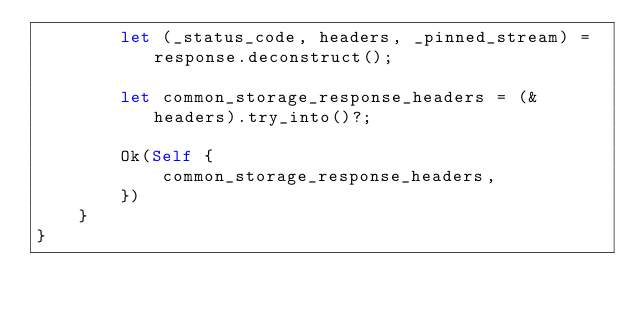<code> <loc_0><loc_0><loc_500><loc_500><_Rust_>        let (_status_code, headers, _pinned_stream) = response.deconstruct();

        let common_storage_response_headers = (&headers).try_into()?;

        Ok(Self {
            common_storage_response_headers,
        })
    }
}
</code> 